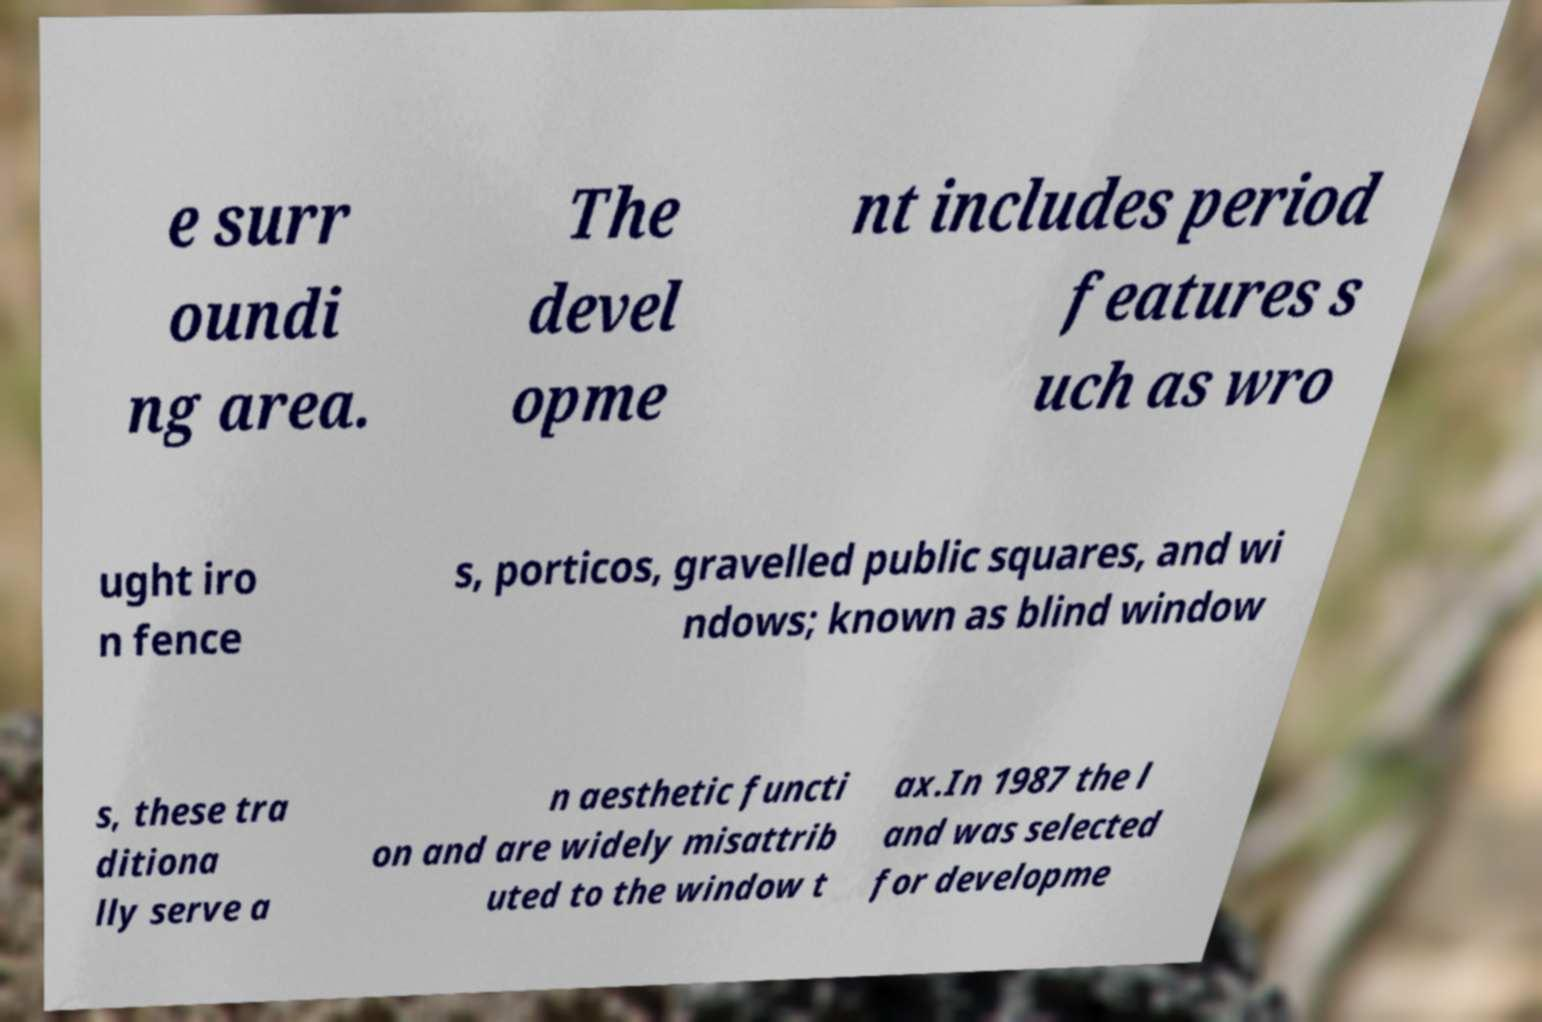Please read and relay the text visible in this image. What does it say? e surr oundi ng area. The devel opme nt includes period features s uch as wro ught iro n fence s, porticos, gravelled public squares, and wi ndows; known as blind window s, these tra ditiona lly serve a n aesthetic functi on and are widely misattrib uted to the window t ax.In 1987 the l and was selected for developme 